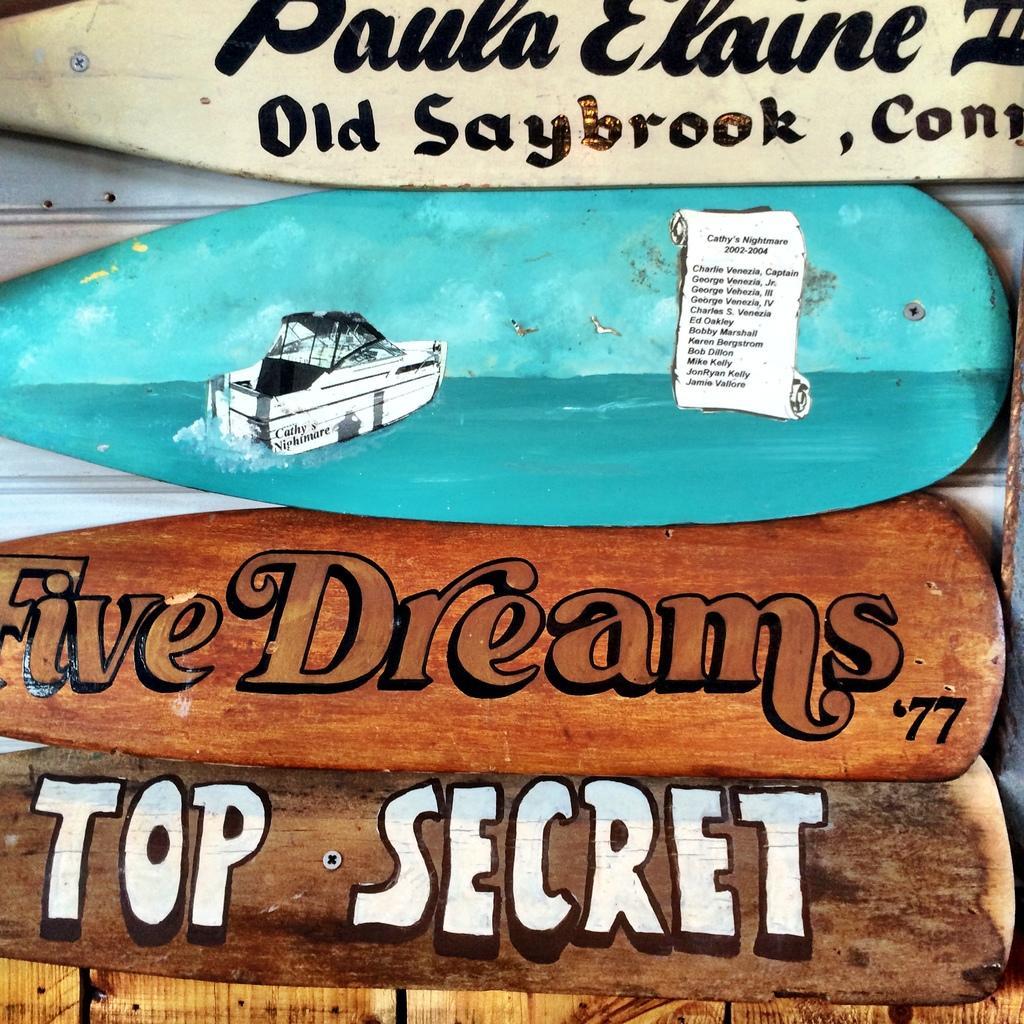How would you summarize this image in a sentence or two? In this picture, we see the wooden boards in blue, brown and white color. We see some text written on each board. In the background, it is white in color and it might be a table. At the bottom, we see a wooden table. 